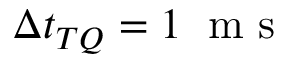<formula> <loc_0><loc_0><loc_500><loc_500>\Delta t _ { T Q } = 1 \, m s</formula> 